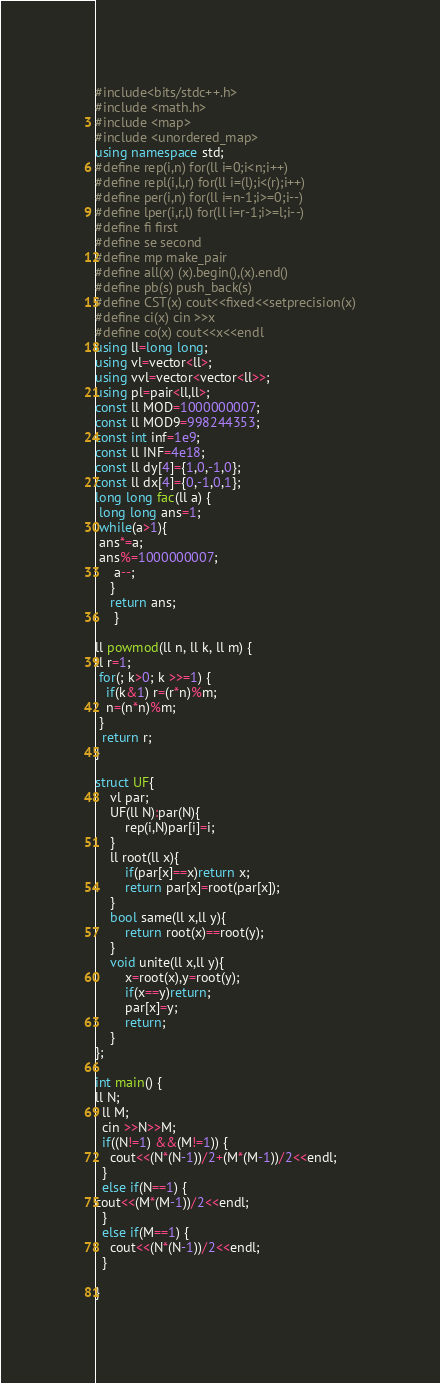<code> <loc_0><loc_0><loc_500><loc_500><_C++_>#include<bits/stdc++.h>
#include <math.h>
#include <map>
#include <unordered_map>
using namespace std;
#define rep(i,n) for(ll i=0;i<n;i++)
#define repl(i,l,r) for(ll i=(l);i<(r);i++)
#define per(i,n) for(ll i=n-1;i>=0;i--)
#define lper(i,r,l) for(ll i=r-1;i>=l;i--)
#define fi first
#define se second
#define mp make_pair
#define all(x) (x).begin(),(x).end()
#define pb(s) push_back(s)
#define CST(x) cout<<fixed<<setprecision(x)
#define ci(x) cin >>x
#define co(x) cout<<x<<endl
using ll=long long;
using vl=vector<ll>;
using vvl=vector<vector<ll>>;
using pl=pair<ll,ll>;
const ll MOD=1000000007;
const ll MOD9=998244353;
const int inf=1e9;
const ll INF=4e18;
const ll dy[4]={1,0,-1,0};
const ll dx[4]={0,-1,0,1};
long long fac(ll a) {
 long long ans=1;
 while(a>1){
 ans*=a;
 ans%=1000000007;
     a--;
    }
    return ans;
     }

ll powmod(ll n, ll k, ll m) {
ll r=1;
 for(; k>0; k >>=1) {
   if(k&1) r=(r*n)%m;
   n=(n*n)%m;
 }
  return r;
}

struct UF{
    vl par;
    UF(ll N):par(N){
        rep(i,N)par[i]=i;
    }
    ll root(ll x){
        if(par[x]==x)return x;
        return par[x]=root(par[x]);
    }
    bool same(ll x,ll y){
        return root(x)==root(y);
    }
    void unite(ll x,ll y){
        x=root(x),y=root(y);
        if(x==y)return;
        par[x]=y;
        return;
    }
};

int main() {
ll N;
  ll M;
  cin >>N>>M;
  if((N!=1) &&(M!=1)) {
    cout<<(N*(N-1))/2+(M*(M-1))/2<<endl;
  }
  else if(N==1) {
cout<<(M*(M-1))/2<<endl;
  }
  else if(M==1) {
    cout<<(N*(N-1))/2<<endl;
  }
  
}</code> 